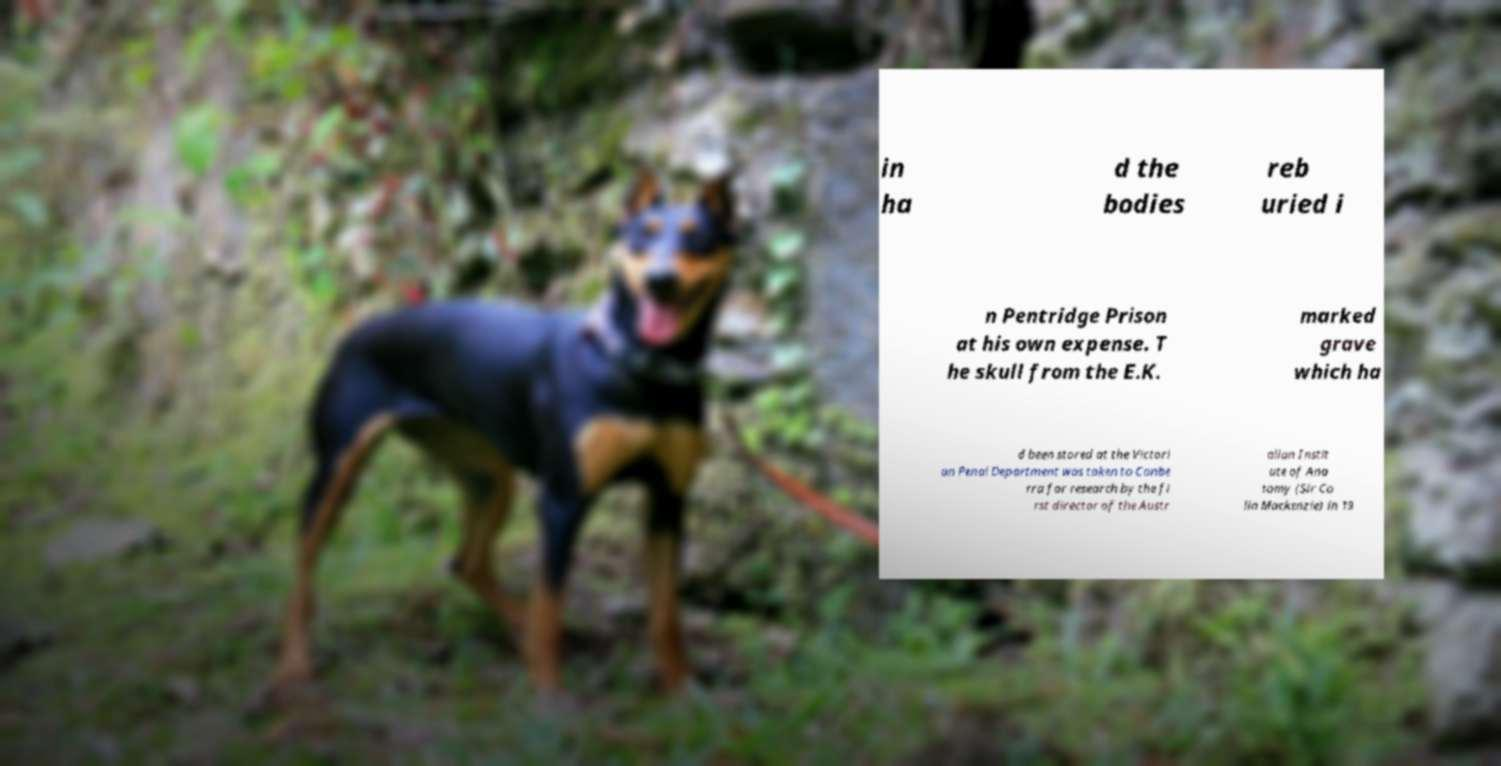Could you extract and type out the text from this image? in ha d the bodies reb uried i n Pentridge Prison at his own expense. T he skull from the E.K. marked grave which ha d been stored at the Victori an Penal Department was taken to Canbe rra for research by the fi rst director of the Austr alian Instit ute of Ana tomy (Sir Co lin Mackenzie) in 19 